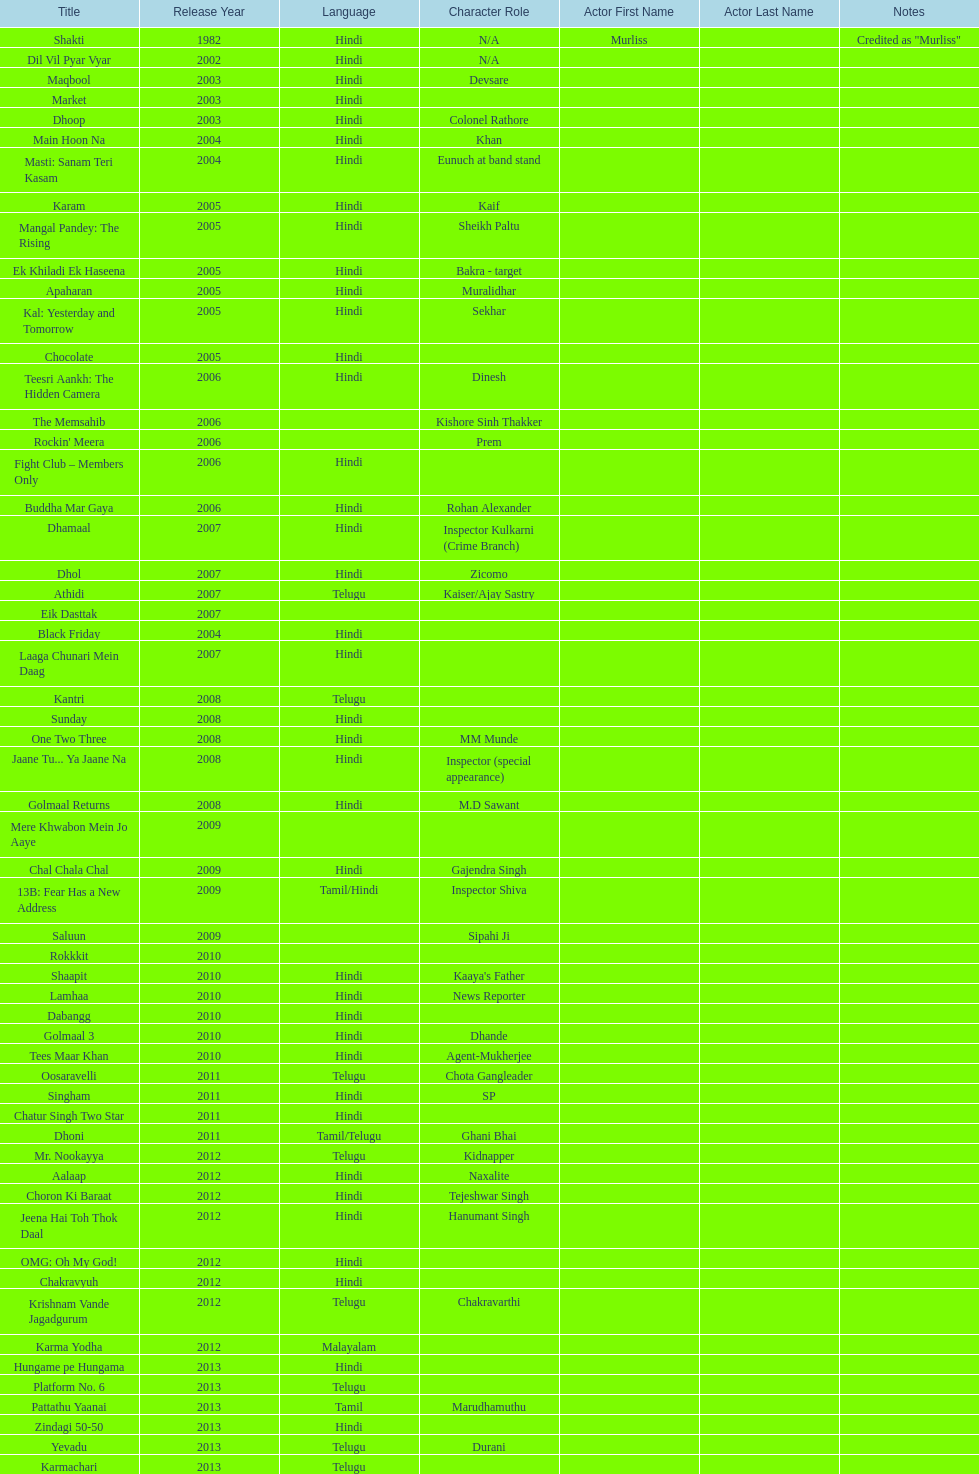How many roles has this actor had? 36. 